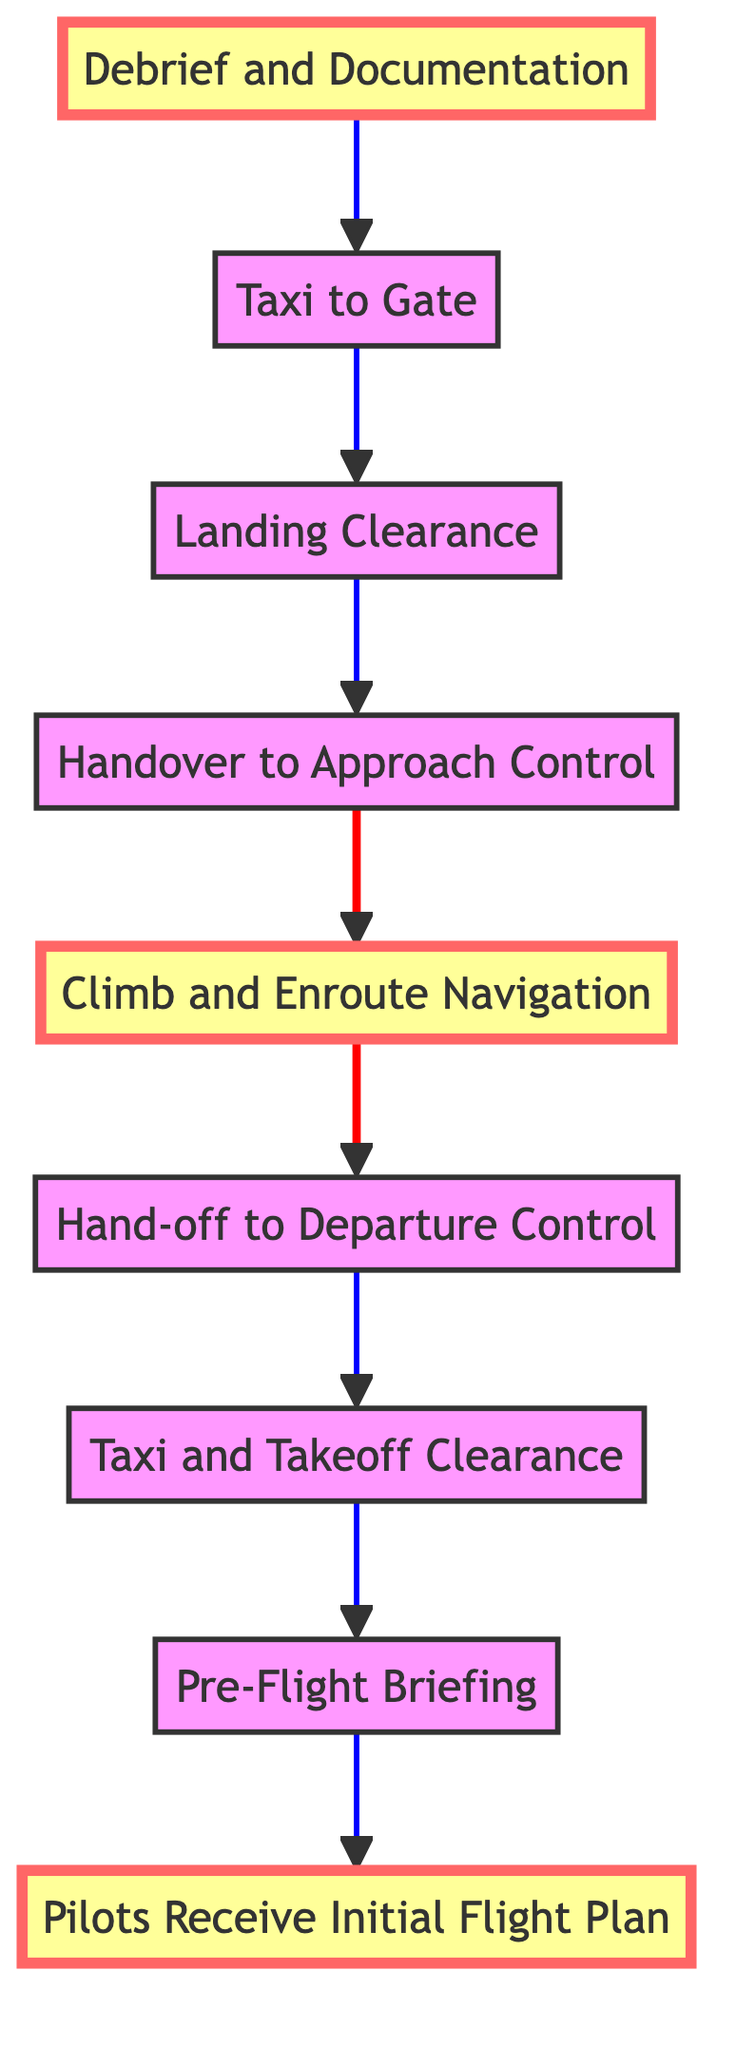What is the first step in the flow? The first step is represented at the bottom of the flow chart, which is "Pilots Receive Initial Flight Plan." This is the starting point of the communication process.
Answer: Pilots Receive Initial Flight Plan What step follows "Taxi and Takeoff Clearance"? In the flow, the step that follows "Taxi and Takeoff Clearance" is "Hand-off to Departure Control," as indicated by the directed edge above it.
Answer: Hand-off to Departure Control How many total steps are in the diagram? Counting all the nodes in the diagram, there are a total of nine steps, starting from "Pilots Receive Initial Flight Plan" to "Debrief and Documentation."
Answer: Nine What are the highlighted steps in the diagram? The highlighted steps indicate important stages in the communication flow: "Pilots Receive Initial Flight Plan," "Climb and Enroute Navigation," and "Debrief and Documentation." These are visually emphasized to show their significance in the process.
Answer: Pilots Receive Initial Flight Plan, Climb and Enroute Navigation, Debrief and Documentation What connects "Landing Clearance" and "Taxi to Gate"? The connection between "Landing Clearance" and "Taxi to Gate" is a one-way directed edge that indicates the transition from one step to the next in the sequence, illustrating the flow of communication from receiving landing instructions to taxiing to the gate.
Answer: One-way directed edge What happens after "Handover to Approach Control"? The step that occurs directly after "Handover to Approach Control" is "Landing Clearance," as it follows in the upward flow of the diagram, showing that once the aircraft is handed over for landing, the pilots receive clearance instructions.
Answer: Landing Clearance How does the flow illustrate communication coordination? The flow illustrates communication coordination by demonstrating the sequential steps and direct connections among various phases, showing how information is relayed between pilots and air traffic control from flight planning to the debriefing after landing.
Answer: Sequential steps and direct connections Which step indicates the transition from taxiing to landing? The step that indicates this transition is "Handover to Approach Control," showing that after taxiing, there is a specific handover to the control responsible for managing the landing procedures.
Answer: Handover to Approach Control 